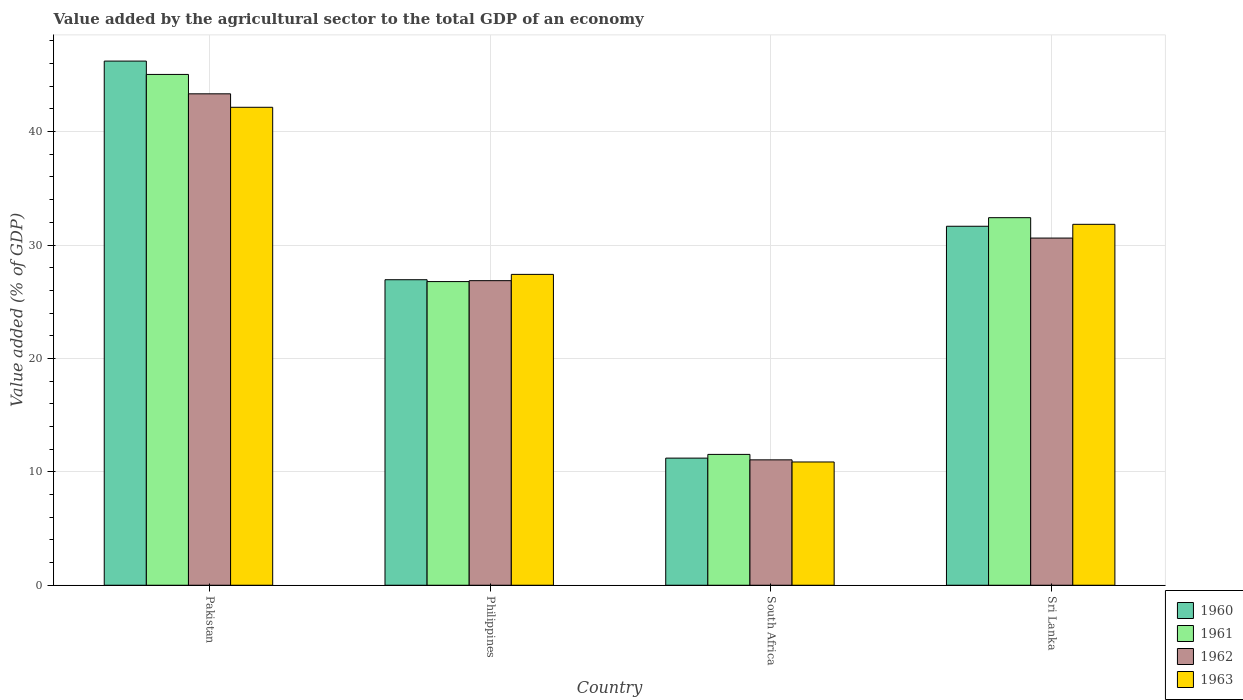Are the number of bars per tick equal to the number of legend labels?
Your response must be concise. Yes. Are the number of bars on each tick of the X-axis equal?
Keep it short and to the point. Yes. How many bars are there on the 4th tick from the left?
Keep it short and to the point. 4. How many bars are there on the 2nd tick from the right?
Provide a succinct answer. 4. What is the value added by the agricultural sector to the total GDP in 1962 in Pakistan?
Offer a terse response. 43.33. Across all countries, what is the maximum value added by the agricultural sector to the total GDP in 1960?
Provide a succinct answer. 46.22. Across all countries, what is the minimum value added by the agricultural sector to the total GDP in 1961?
Provide a short and direct response. 11.54. In which country was the value added by the agricultural sector to the total GDP in 1960 minimum?
Your answer should be compact. South Africa. What is the total value added by the agricultural sector to the total GDP in 1962 in the graph?
Provide a short and direct response. 111.86. What is the difference between the value added by the agricultural sector to the total GDP in 1960 in South Africa and that in Sri Lanka?
Ensure brevity in your answer.  -20.45. What is the difference between the value added by the agricultural sector to the total GDP in 1961 in Philippines and the value added by the agricultural sector to the total GDP in 1960 in Sri Lanka?
Your response must be concise. -4.88. What is the average value added by the agricultural sector to the total GDP in 1960 per country?
Offer a very short reply. 29.01. What is the difference between the value added by the agricultural sector to the total GDP of/in 1963 and value added by the agricultural sector to the total GDP of/in 1961 in Sri Lanka?
Give a very brief answer. -0.59. What is the ratio of the value added by the agricultural sector to the total GDP in 1963 in Pakistan to that in South Africa?
Ensure brevity in your answer.  3.88. Is the difference between the value added by the agricultural sector to the total GDP in 1963 in Pakistan and South Africa greater than the difference between the value added by the agricultural sector to the total GDP in 1961 in Pakistan and South Africa?
Provide a succinct answer. No. What is the difference between the highest and the second highest value added by the agricultural sector to the total GDP in 1963?
Your answer should be compact. 14.73. What is the difference between the highest and the lowest value added by the agricultural sector to the total GDP in 1963?
Keep it short and to the point. 31.28. In how many countries, is the value added by the agricultural sector to the total GDP in 1962 greater than the average value added by the agricultural sector to the total GDP in 1962 taken over all countries?
Make the answer very short. 2. What does the 3rd bar from the right in South Africa represents?
Keep it short and to the point. 1961. Is it the case that in every country, the sum of the value added by the agricultural sector to the total GDP in 1963 and value added by the agricultural sector to the total GDP in 1961 is greater than the value added by the agricultural sector to the total GDP in 1960?
Provide a succinct answer. Yes. How many bars are there?
Offer a very short reply. 16. How many countries are there in the graph?
Provide a succinct answer. 4. Are the values on the major ticks of Y-axis written in scientific E-notation?
Your answer should be compact. No. Where does the legend appear in the graph?
Make the answer very short. Bottom right. What is the title of the graph?
Your answer should be very brief. Value added by the agricultural sector to the total GDP of an economy. What is the label or title of the X-axis?
Your response must be concise. Country. What is the label or title of the Y-axis?
Keep it short and to the point. Value added (% of GDP). What is the Value added (% of GDP) in 1960 in Pakistan?
Keep it short and to the point. 46.22. What is the Value added (% of GDP) in 1961 in Pakistan?
Your answer should be very brief. 45.04. What is the Value added (% of GDP) of 1962 in Pakistan?
Ensure brevity in your answer.  43.33. What is the Value added (% of GDP) of 1963 in Pakistan?
Keep it short and to the point. 42.15. What is the Value added (% of GDP) of 1960 in Philippines?
Give a very brief answer. 26.94. What is the Value added (% of GDP) in 1961 in Philippines?
Make the answer very short. 26.78. What is the Value added (% of GDP) of 1962 in Philippines?
Make the answer very short. 26.86. What is the Value added (% of GDP) in 1963 in Philippines?
Keep it short and to the point. 27.41. What is the Value added (% of GDP) of 1960 in South Africa?
Your answer should be compact. 11.21. What is the Value added (% of GDP) in 1961 in South Africa?
Your response must be concise. 11.54. What is the Value added (% of GDP) in 1962 in South Africa?
Make the answer very short. 11.06. What is the Value added (% of GDP) of 1963 in South Africa?
Make the answer very short. 10.87. What is the Value added (% of GDP) of 1960 in Sri Lanka?
Provide a succinct answer. 31.66. What is the Value added (% of GDP) of 1961 in Sri Lanka?
Give a very brief answer. 32.41. What is the Value added (% of GDP) of 1962 in Sri Lanka?
Give a very brief answer. 30.61. What is the Value added (% of GDP) in 1963 in Sri Lanka?
Provide a short and direct response. 31.83. Across all countries, what is the maximum Value added (% of GDP) in 1960?
Your response must be concise. 46.22. Across all countries, what is the maximum Value added (% of GDP) in 1961?
Make the answer very short. 45.04. Across all countries, what is the maximum Value added (% of GDP) in 1962?
Offer a very short reply. 43.33. Across all countries, what is the maximum Value added (% of GDP) in 1963?
Give a very brief answer. 42.15. Across all countries, what is the minimum Value added (% of GDP) of 1960?
Give a very brief answer. 11.21. Across all countries, what is the minimum Value added (% of GDP) of 1961?
Your answer should be very brief. 11.54. Across all countries, what is the minimum Value added (% of GDP) in 1962?
Ensure brevity in your answer.  11.06. Across all countries, what is the minimum Value added (% of GDP) of 1963?
Provide a short and direct response. 10.87. What is the total Value added (% of GDP) in 1960 in the graph?
Make the answer very short. 116.03. What is the total Value added (% of GDP) in 1961 in the graph?
Offer a very short reply. 115.77. What is the total Value added (% of GDP) of 1962 in the graph?
Provide a succinct answer. 111.86. What is the total Value added (% of GDP) of 1963 in the graph?
Your response must be concise. 112.25. What is the difference between the Value added (% of GDP) of 1960 in Pakistan and that in Philippines?
Your answer should be compact. 19.28. What is the difference between the Value added (% of GDP) of 1961 in Pakistan and that in Philippines?
Your answer should be very brief. 18.27. What is the difference between the Value added (% of GDP) in 1962 in Pakistan and that in Philippines?
Provide a short and direct response. 16.48. What is the difference between the Value added (% of GDP) of 1963 in Pakistan and that in Philippines?
Ensure brevity in your answer.  14.73. What is the difference between the Value added (% of GDP) in 1960 in Pakistan and that in South Africa?
Provide a succinct answer. 35.01. What is the difference between the Value added (% of GDP) in 1961 in Pakistan and that in South Africa?
Offer a terse response. 33.51. What is the difference between the Value added (% of GDP) in 1962 in Pakistan and that in South Africa?
Your response must be concise. 32.28. What is the difference between the Value added (% of GDP) in 1963 in Pakistan and that in South Africa?
Offer a very short reply. 31.28. What is the difference between the Value added (% of GDP) in 1960 in Pakistan and that in Sri Lanka?
Your answer should be very brief. 14.56. What is the difference between the Value added (% of GDP) of 1961 in Pakistan and that in Sri Lanka?
Give a very brief answer. 12.63. What is the difference between the Value added (% of GDP) in 1962 in Pakistan and that in Sri Lanka?
Offer a very short reply. 12.72. What is the difference between the Value added (% of GDP) of 1963 in Pakistan and that in Sri Lanka?
Give a very brief answer. 10.32. What is the difference between the Value added (% of GDP) in 1960 in Philippines and that in South Africa?
Your answer should be compact. 15.73. What is the difference between the Value added (% of GDP) in 1961 in Philippines and that in South Africa?
Offer a terse response. 15.24. What is the difference between the Value added (% of GDP) in 1962 in Philippines and that in South Africa?
Offer a terse response. 15.8. What is the difference between the Value added (% of GDP) in 1963 in Philippines and that in South Africa?
Keep it short and to the point. 16.54. What is the difference between the Value added (% of GDP) of 1960 in Philippines and that in Sri Lanka?
Provide a succinct answer. -4.72. What is the difference between the Value added (% of GDP) of 1961 in Philippines and that in Sri Lanka?
Your answer should be compact. -5.63. What is the difference between the Value added (% of GDP) of 1962 in Philippines and that in Sri Lanka?
Give a very brief answer. -3.76. What is the difference between the Value added (% of GDP) of 1963 in Philippines and that in Sri Lanka?
Provide a short and direct response. -4.41. What is the difference between the Value added (% of GDP) of 1960 in South Africa and that in Sri Lanka?
Give a very brief answer. -20.45. What is the difference between the Value added (% of GDP) of 1961 in South Africa and that in Sri Lanka?
Provide a succinct answer. -20.87. What is the difference between the Value added (% of GDP) of 1962 in South Africa and that in Sri Lanka?
Provide a short and direct response. -19.56. What is the difference between the Value added (% of GDP) of 1963 in South Africa and that in Sri Lanka?
Make the answer very short. -20.96. What is the difference between the Value added (% of GDP) of 1960 in Pakistan and the Value added (% of GDP) of 1961 in Philippines?
Offer a terse response. 19.44. What is the difference between the Value added (% of GDP) in 1960 in Pakistan and the Value added (% of GDP) in 1962 in Philippines?
Keep it short and to the point. 19.36. What is the difference between the Value added (% of GDP) in 1960 in Pakistan and the Value added (% of GDP) in 1963 in Philippines?
Your answer should be compact. 18.81. What is the difference between the Value added (% of GDP) of 1961 in Pakistan and the Value added (% of GDP) of 1962 in Philippines?
Your response must be concise. 18.19. What is the difference between the Value added (% of GDP) in 1961 in Pakistan and the Value added (% of GDP) in 1963 in Philippines?
Provide a short and direct response. 17.63. What is the difference between the Value added (% of GDP) in 1962 in Pakistan and the Value added (% of GDP) in 1963 in Philippines?
Provide a succinct answer. 15.92. What is the difference between the Value added (% of GDP) of 1960 in Pakistan and the Value added (% of GDP) of 1961 in South Africa?
Provide a short and direct response. 34.68. What is the difference between the Value added (% of GDP) of 1960 in Pakistan and the Value added (% of GDP) of 1962 in South Africa?
Offer a terse response. 35.16. What is the difference between the Value added (% of GDP) in 1960 in Pakistan and the Value added (% of GDP) in 1963 in South Africa?
Your answer should be compact. 35.35. What is the difference between the Value added (% of GDP) of 1961 in Pakistan and the Value added (% of GDP) of 1962 in South Africa?
Provide a succinct answer. 33.99. What is the difference between the Value added (% of GDP) in 1961 in Pakistan and the Value added (% of GDP) in 1963 in South Africa?
Your response must be concise. 34.17. What is the difference between the Value added (% of GDP) of 1962 in Pakistan and the Value added (% of GDP) of 1963 in South Africa?
Your answer should be very brief. 32.46. What is the difference between the Value added (% of GDP) of 1960 in Pakistan and the Value added (% of GDP) of 1961 in Sri Lanka?
Keep it short and to the point. 13.81. What is the difference between the Value added (% of GDP) in 1960 in Pakistan and the Value added (% of GDP) in 1962 in Sri Lanka?
Make the answer very short. 15.61. What is the difference between the Value added (% of GDP) in 1960 in Pakistan and the Value added (% of GDP) in 1963 in Sri Lanka?
Your response must be concise. 14.39. What is the difference between the Value added (% of GDP) in 1961 in Pakistan and the Value added (% of GDP) in 1962 in Sri Lanka?
Provide a short and direct response. 14.43. What is the difference between the Value added (% of GDP) of 1961 in Pakistan and the Value added (% of GDP) of 1963 in Sri Lanka?
Make the answer very short. 13.22. What is the difference between the Value added (% of GDP) in 1962 in Pakistan and the Value added (% of GDP) in 1963 in Sri Lanka?
Make the answer very short. 11.51. What is the difference between the Value added (% of GDP) in 1960 in Philippines and the Value added (% of GDP) in 1961 in South Africa?
Your answer should be compact. 15.4. What is the difference between the Value added (% of GDP) in 1960 in Philippines and the Value added (% of GDP) in 1962 in South Africa?
Offer a very short reply. 15.88. What is the difference between the Value added (% of GDP) in 1960 in Philippines and the Value added (% of GDP) in 1963 in South Africa?
Give a very brief answer. 16.07. What is the difference between the Value added (% of GDP) in 1961 in Philippines and the Value added (% of GDP) in 1962 in South Africa?
Your response must be concise. 15.72. What is the difference between the Value added (% of GDP) of 1961 in Philippines and the Value added (% of GDP) of 1963 in South Africa?
Your answer should be very brief. 15.91. What is the difference between the Value added (% of GDP) of 1962 in Philippines and the Value added (% of GDP) of 1963 in South Africa?
Provide a short and direct response. 15.99. What is the difference between the Value added (% of GDP) of 1960 in Philippines and the Value added (% of GDP) of 1961 in Sri Lanka?
Keep it short and to the point. -5.47. What is the difference between the Value added (% of GDP) in 1960 in Philippines and the Value added (% of GDP) in 1962 in Sri Lanka?
Offer a very short reply. -3.67. What is the difference between the Value added (% of GDP) in 1960 in Philippines and the Value added (% of GDP) in 1963 in Sri Lanka?
Your answer should be very brief. -4.89. What is the difference between the Value added (% of GDP) in 1961 in Philippines and the Value added (% of GDP) in 1962 in Sri Lanka?
Your answer should be very brief. -3.84. What is the difference between the Value added (% of GDP) in 1961 in Philippines and the Value added (% of GDP) in 1963 in Sri Lanka?
Your answer should be very brief. -5.05. What is the difference between the Value added (% of GDP) in 1962 in Philippines and the Value added (% of GDP) in 1963 in Sri Lanka?
Your response must be concise. -4.97. What is the difference between the Value added (% of GDP) in 1960 in South Africa and the Value added (% of GDP) in 1961 in Sri Lanka?
Make the answer very short. -21.2. What is the difference between the Value added (% of GDP) of 1960 in South Africa and the Value added (% of GDP) of 1962 in Sri Lanka?
Your answer should be compact. -19.4. What is the difference between the Value added (% of GDP) in 1960 in South Africa and the Value added (% of GDP) in 1963 in Sri Lanka?
Make the answer very short. -20.62. What is the difference between the Value added (% of GDP) in 1961 in South Africa and the Value added (% of GDP) in 1962 in Sri Lanka?
Provide a succinct answer. -19.08. What is the difference between the Value added (% of GDP) of 1961 in South Africa and the Value added (% of GDP) of 1963 in Sri Lanka?
Provide a short and direct response. -20.29. What is the difference between the Value added (% of GDP) of 1962 in South Africa and the Value added (% of GDP) of 1963 in Sri Lanka?
Ensure brevity in your answer.  -20.77. What is the average Value added (% of GDP) of 1960 per country?
Offer a very short reply. 29.01. What is the average Value added (% of GDP) in 1961 per country?
Your response must be concise. 28.94. What is the average Value added (% of GDP) of 1962 per country?
Ensure brevity in your answer.  27.97. What is the average Value added (% of GDP) in 1963 per country?
Your answer should be compact. 28.06. What is the difference between the Value added (% of GDP) of 1960 and Value added (% of GDP) of 1961 in Pakistan?
Provide a short and direct response. 1.18. What is the difference between the Value added (% of GDP) of 1960 and Value added (% of GDP) of 1962 in Pakistan?
Make the answer very short. 2.89. What is the difference between the Value added (% of GDP) of 1960 and Value added (% of GDP) of 1963 in Pakistan?
Your answer should be very brief. 4.07. What is the difference between the Value added (% of GDP) of 1961 and Value added (% of GDP) of 1962 in Pakistan?
Give a very brief answer. 1.71. What is the difference between the Value added (% of GDP) of 1961 and Value added (% of GDP) of 1963 in Pakistan?
Your answer should be very brief. 2.9. What is the difference between the Value added (% of GDP) of 1962 and Value added (% of GDP) of 1963 in Pakistan?
Provide a succinct answer. 1.19. What is the difference between the Value added (% of GDP) of 1960 and Value added (% of GDP) of 1961 in Philippines?
Provide a short and direct response. 0.16. What is the difference between the Value added (% of GDP) of 1960 and Value added (% of GDP) of 1962 in Philippines?
Offer a terse response. 0.08. What is the difference between the Value added (% of GDP) in 1960 and Value added (% of GDP) in 1963 in Philippines?
Make the answer very short. -0.47. What is the difference between the Value added (% of GDP) in 1961 and Value added (% of GDP) in 1962 in Philippines?
Give a very brief answer. -0.08. What is the difference between the Value added (% of GDP) of 1961 and Value added (% of GDP) of 1963 in Philippines?
Your answer should be compact. -0.64. What is the difference between the Value added (% of GDP) of 1962 and Value added (% of GDP) of 1963 in Philippines?
Your answer should be compact. -0.55. What is the difference between the Value added (% of GDP) in 1960 and Value added (% of GDP) in 1961 in South Africa?
Keep it short and to the point. -0.33. What is the difference between the Value added (% of GDP) of 1960 and Value added (% of GDP) of 1962 in South Africa?
Offer a very short reply. 0.15. What is the difference between the Value added (% of GDP) in 1960 and Value added (% of GDP) in 1963 in South Africa?
Ensure brevity in your answer.  0.34. What is the difference between the Value added (% of GDP) of 1961 and Value added (% of GDP) of 1962 in South Africa?
Offer a very short reply. 0.48. What is the difference between the Value added (% of GDP) of 1961 and Value added (% of GDP) of 1963 in South Africa?
Keep it short and to the point. 0.67. What is the difference between the Value added (% of GDP) in 1962 and Value added (% of GDP) in 1963 in South Africa?
Make the answer very short. 0.19. What is the difference between the Value added (% of GDP) in 1960 and Value added (% of GDP) in 1961 in Sri Lanka?
Give a very brief answer. -0.76. What is the difference between the Value added (% of GDP) in 1960 and Value added (% of GDP) in 1962 in Sri Lanka?
Your answer should be compact. 1.04. What is the difference between the Value added (% of GDP) of 1960 and Value added (% of GDP) of 1963 in Sri Lanka?
Give a very brief answer. -0.17. What is the difference between the Value added (% of GDP) of 1961 and Value added (% of GDP) of 1962 in Sri Lanka?
Provide a succinct answer. 1.8. What is the difference between the Value added (% of GDP) in 1961 and Value added (% of GDP) in 1963 in Sri Lanka?
Offer a terse response. 0.59. What is the difference between the Value added (% of GDP) of 1962 and Value added (% of GDP) of 1963 in Sri Lanka?
Your response must be concise. -1.21. What is the ratio of the Value added (% of GDP) in 1960 in Pakistan to that in Philippines?
Make the answer very short. 1.72. What is the ratio of the Value added (% of GDP) in 1961 in Pakistan to that in Philippines?
Keep it short and to the point. 1.68. What is the ratio of the Value added (% of GDP) of 1962 in Pakistan to that in Philippines?
Give a very brief answer. 1.61. What is the ratio of the Value added (% of GDP) of 1963 in Pakistan to that in Philippines?
Your answer should be compact. 1.54. What is the ratio of the Value added (% of GDP) in 1960 in Pakistan to that in South Africa?
Offer a very short reply. 4.12. What is the ratio of the Value added (% of GDP) of 1961 in Pakistan to that in South Africa?
Your response must be concise. 3.9. What is the ratio of the Value added (% of GDP) in 1962 in Pakistan to that in South Africa?
Offer a terse response. 3.92. What is the ratio of the Value added (% of GDP) in 1963 in Pakistan to that in South Africa?
Keep it short and to the point. 3.88. What is the ratio of the Value added (% of GDP) in 1960 in Pakistan to that in Sri Lanka?
Your response must be concise. 1.46. What is the ratio of the Value added (% of GDP) in 1961 in Pakistan to that in Sri Lanka?
Ensure brevity in your answer.  1.39. What is the ratio of the Value added (% of GDP) in 1962 in Pakistan to that in Sri Lanka?
Offer a very short reply. 1.42. What is the ratio of the Value added (% of GDP) in 1963 in Pakistan to that in Sri Lanka?
Give a very brief answer. 1.32. What is the ratio of the Value added (% of GDP) of 1960 in Philippines to that in South Africa?
Keep it short and to the point. 2.4. What is the ratio of the Value added (% of GDP) in 1961 in Philippines to that in South Africa?
Offer a very short reply. 2.32. What is the ratio of the Value added (% of GDP) in 1962 in Philippines to that in South Africa?
Your answer should be compact. 2.43. What is the ratio of the Value added (% of GDP) of 1963 in Philippines to that in South Africa?
Provide a succinct answer. 2.52. What is the ratio of the Value added (% of GDP) in 1960 in Philippines to that in Sri Lanka?
Offer a very short reply. 0.85. What is the ratio of the Value added (% of GDP) in 1961 in Philippines to that in Sri Lanka?
Keep it short and to the point. 0.83. What is the ratio of the Value added (% of GDP) of 1962 in Philippines to that in Sri Lanka?
Your answer should be very brief. 0.88. What is the ratio of the Value added (% of GDP) in 1963 in Philippines to that in Sri Lanka?
Make the answer very short. 0.86. What is the ratio of the Value added (% of GDP) in 1960 in South Africa to that in Sri Lanka?
Make the answer very short. 0.35. What is the ratio of the Value added (% of GDP) in 1961 in South Africa to that in Sri Lanka?
Provide a short and direct response. 0.36. What is the ratio of the Value added (% of GDP) of 1962 in South Africa to that in Sri Lanka?
Provide a short and direct response. 0.36. What is the ratio of the Value added (% of GDP) of 1963 in South Africa to that in Sri Lanka?
Your answer should be compact. 0.34. What is the difference between the highest and the second highest Value added (% of GDP) of 1960?
Offer a terse response. 14.56. What is the difference between the highest and the second highest Value added (% of GDP) in 1961?
Your answer should be compact. 12.63. What is the difference between the highest and the second highest Value added (% of GDP) in 1962?
Give a very brief answer. 12.72. What is the difference between the highest and the second highest Value added (% of GDP) of 1963?
Your answer should be very brief. 10.32. What is the difference between the highest and the lowest Value added (% of GDP) of 1960?
Ensure brevity in your answer.  35.01. What is the difference between the highest and the lowest Value added (% of GDP) of 1961?
Provide a succinct answer. 33.51. What is the difference between the highest and the lowest Value added (% of GDP) of 1962?
Offer a very short reply. 32.28. What is the difference between the highest and the lowest Value added (% of GDP) in 1963?
Provide a succinct answer. 31.28. 